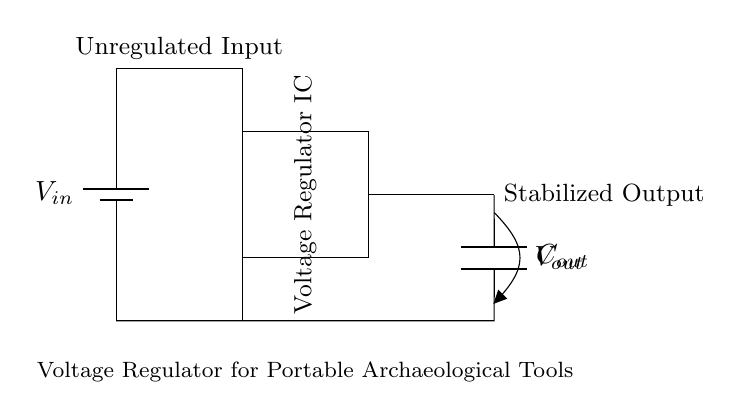What component is used to stabilize the voltage? The circuit uses a Voltage Regulator IC, which regulates and stabilizes the output voltage from the unregulated input.
Answer: Voltage Regulator IC What type of circuit is this? This circuit is a voltage regulator circuit, as indicated by the presence of a voltage regulator component specifically designed to stabilize voltage output.
Answer: Voltage regulator circuit What is the function of the output capacitor? The output capacitor smooths out the fluctuations in voltage, ensuring a stable and consistent output by filtering out noise and providing charge during transient loads.
Answer: Smooth voltage What is the purpose of the input battery? The input battery provides the initial unregulated voltage that the voltage regulator then stabilizes for the connected portable archaeological tools.
Answer: Power supply What is the output voltage denoted as? The output voltage is labeled as V out, indicating the stabilized voltage provided by the voltage regulator to the load.
Answer: V out 